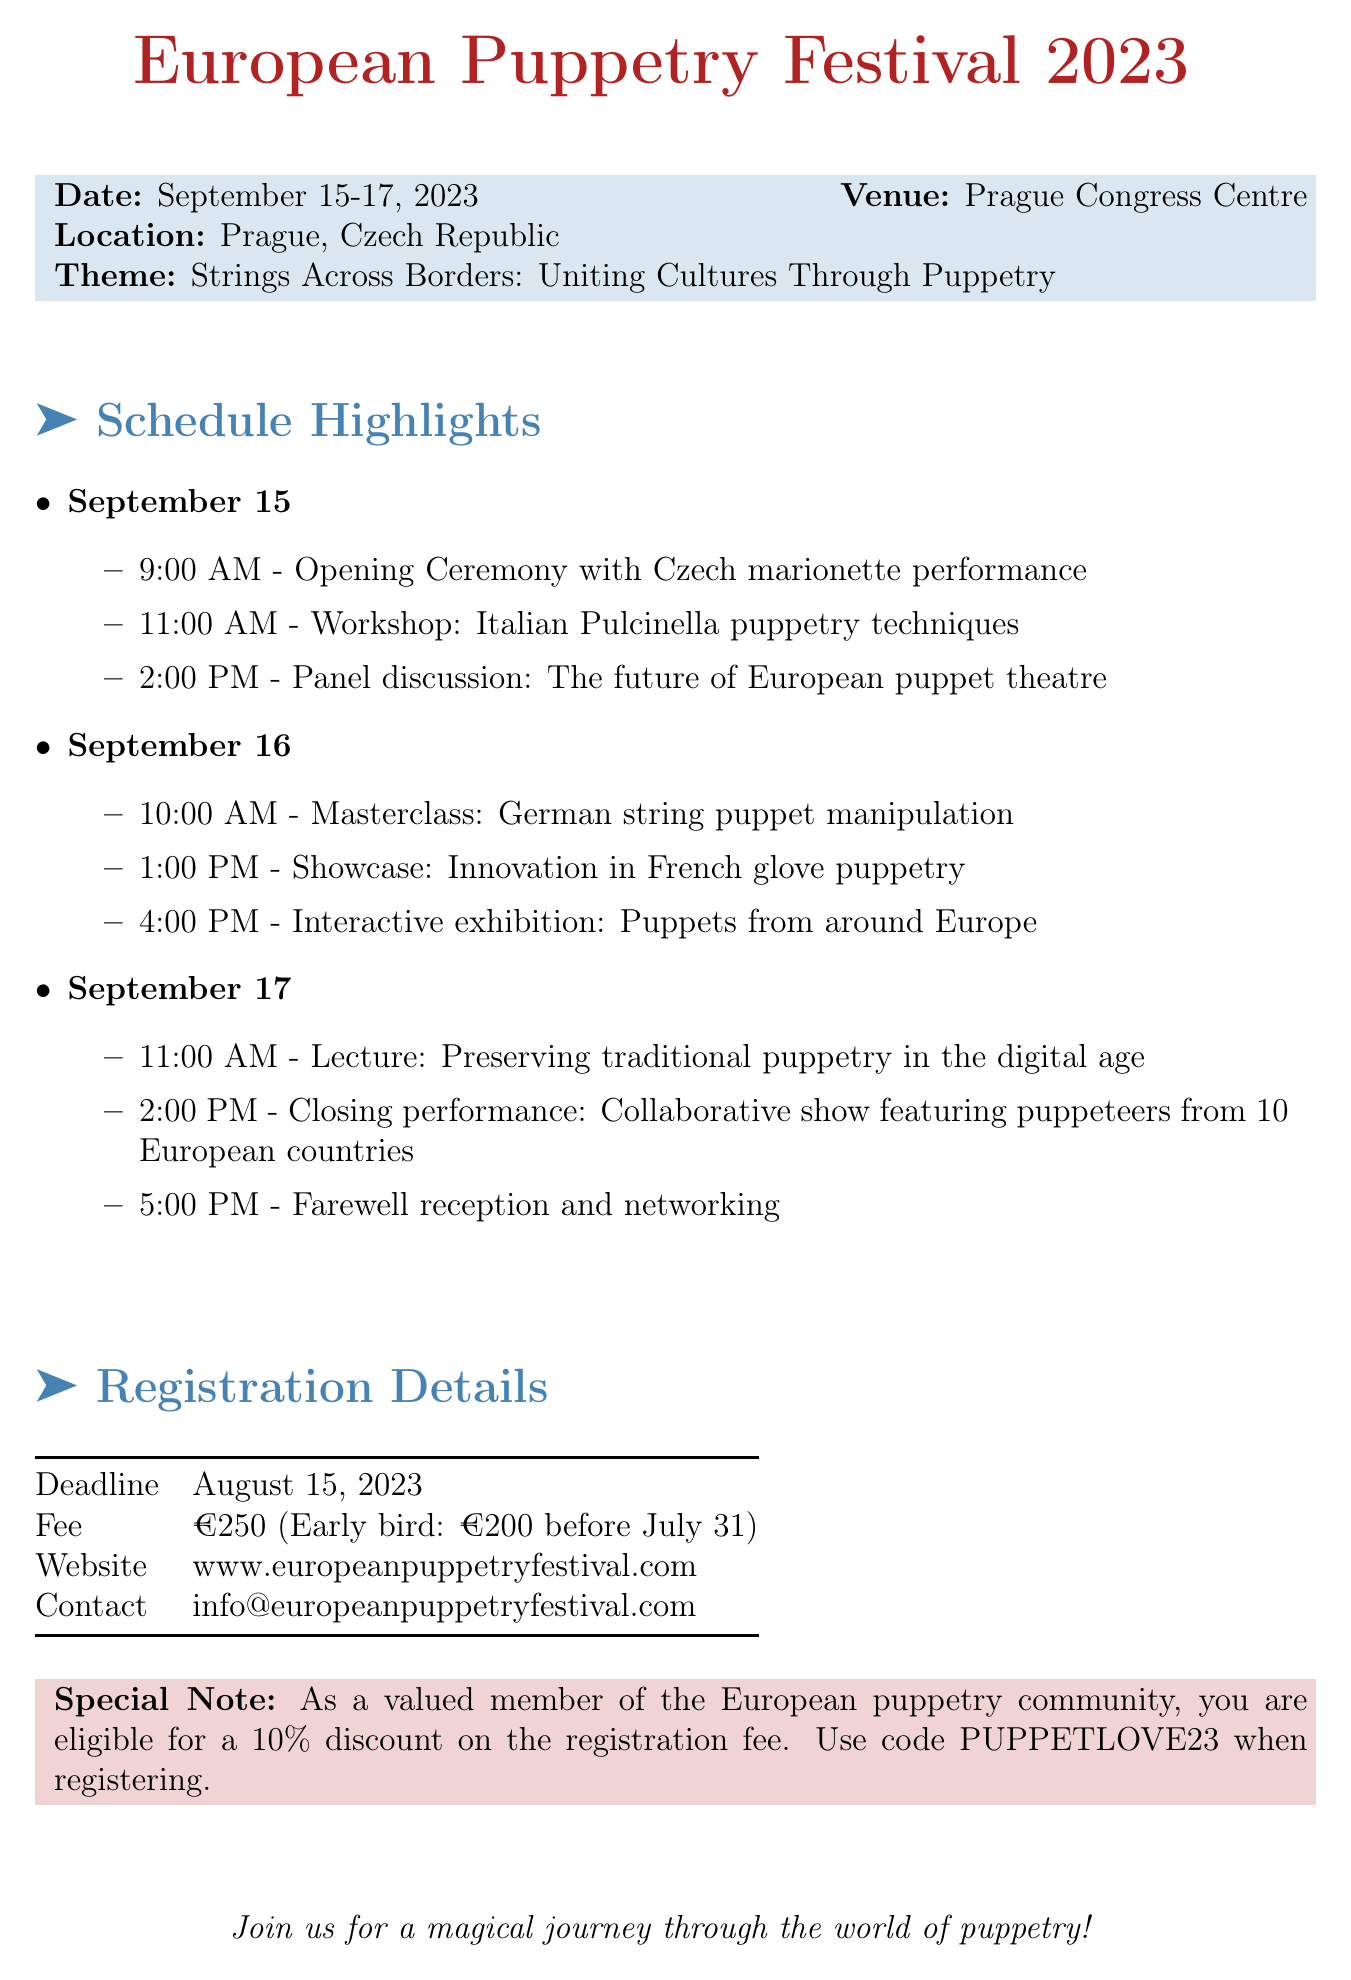What are the dates of the festival? The dates for the festival are mentioned in the document as September 15-17, 2023.
Answer: September 15-17, 2023 Where is the festival taking place? The document provides the location of the event as Prague, Czech Republic.
Answer: Prague, Czech Republic What is the theme of the festival? The theme stated in the document is 'Strings Across Borders: Uniting Cultures Through Puppetry'.
Answer: Strings Across Borders: Uniting Cultures Through Puppetry What is the early bird registration fee? The document specifies the early bird fee as €200 before July 31.
Answer: €200 When is the registration deadline? According to the document, the deadline for registration is August 15, 2023.
Answer: August 15, 2023 What kind of discount is available for community members? The special note in the document mentions a 10% discount for valued community members.
Answer: 10% What type of event is the "Closing performance"? The document describes this event as a collaborative show featuring puppeteers from 10 European countries.
Answer: Collaborative show featuring puppeteers from 10 European countries What is one highlight event on September 16? One of the events on September 16 is the masterclass in German string puppet manipulation.
Answer: Masterclass: German string puppet manipulation What is the website for registration? The document provides the website for registration as www.europeanpuppetryfestival.com.
Answer: www.europeanpuppetryfestival.com 